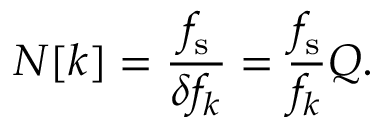<formula> <loc_0><loc_0><loc_500><loc_500>N [ k ] = { \frac { f _ { s } } { \delta f _ { k } } } = { \frac { f _ { s } } { f _ { k } } } Q .</formula> 